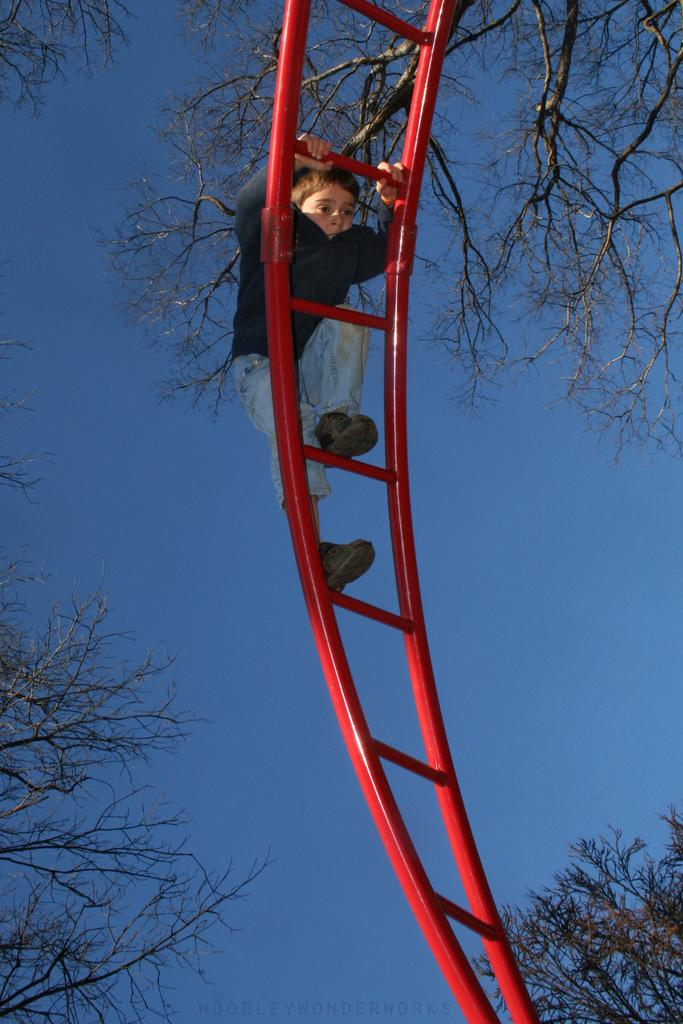What object is present in the image that can be used for climbing? There is a ladder in the image that can be used for climbing. What is the boy in the image doing? The boy is climbing the ladder. What can be seen in the image besides the ladder and the boy? There are branches of a tree in the image. What is visible in the background of the image? The sky is visible in the background of the image. How does the steam from the pickle contribute to the boy's climbing experience in the image? There is no pickle or steam present in the image, so this scenario cannot be observed. 